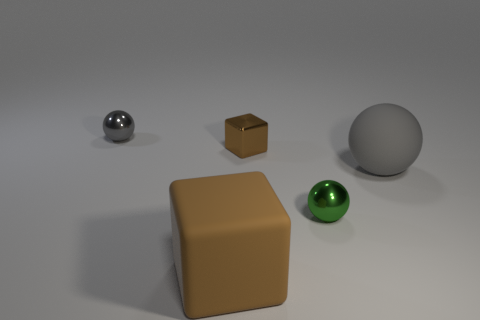How many small metallic things are the same color as the rubber ball?
Provide a succinct answer. 1. Is the number of brown metallic things that are behind the tiny green metal sphere greater than the number of small gray metallic objects?
Offer a very short reply. No. What size is the object that is the same color as the big rubber sphere?
Your response must be concise. Small. Are there any big yellow rubber things of the same shape as the green object?
Give a very brief answer. No. How many things are either tiny shiny blocks or large brown rubber things?
Provide a succinct answer. 2. There is a large matte thing that is to the left of the brown shiny object on the right side of the gray metal thing; how many small brown metallic blocks are left of it?
Your response must be concise. 0. What material is the other big object that is the same shape as the brown shiny object?
Your response must be concise. Rubber. What material is the sphere that is both to the right of the large matte cube and on the left side of the big gray ball?
Your answer should be very brief. Metal. Are there fewer brown blocks behind the green shiny thing than gray balls behind the tiny brown object?
Make the answer very short. No. How many other objects are there of the same size as the brown shiny thing?
Offer a very short reply. 2. 